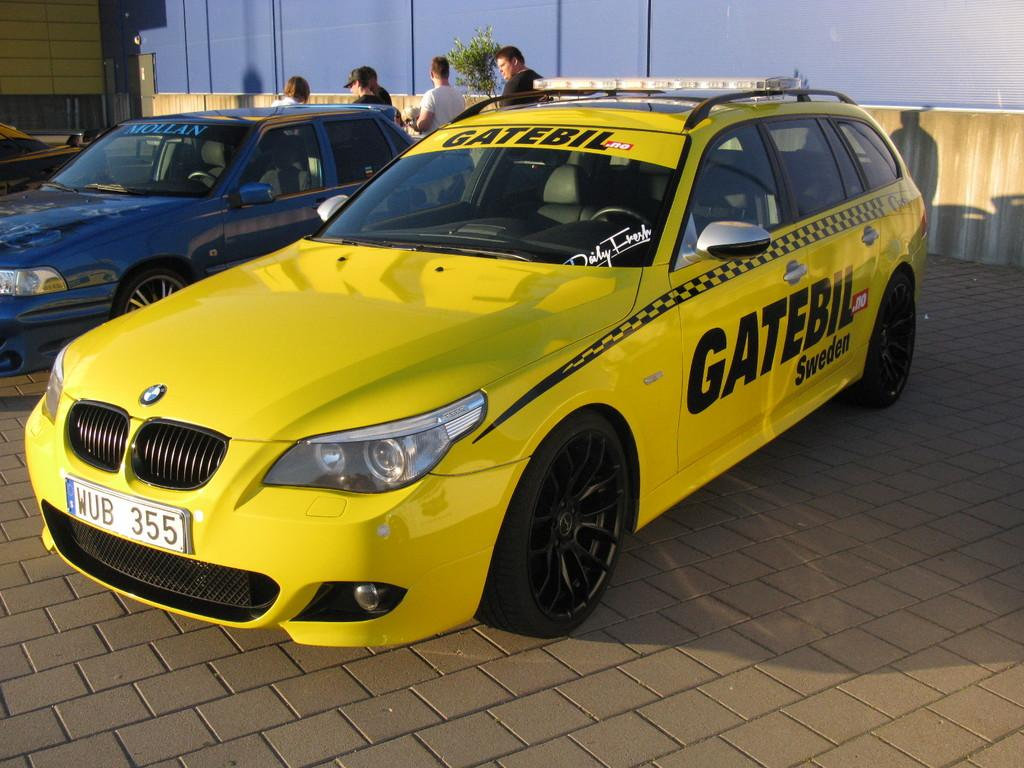<image>
Describe the image concisely. a car that says Gatebil on it outside 